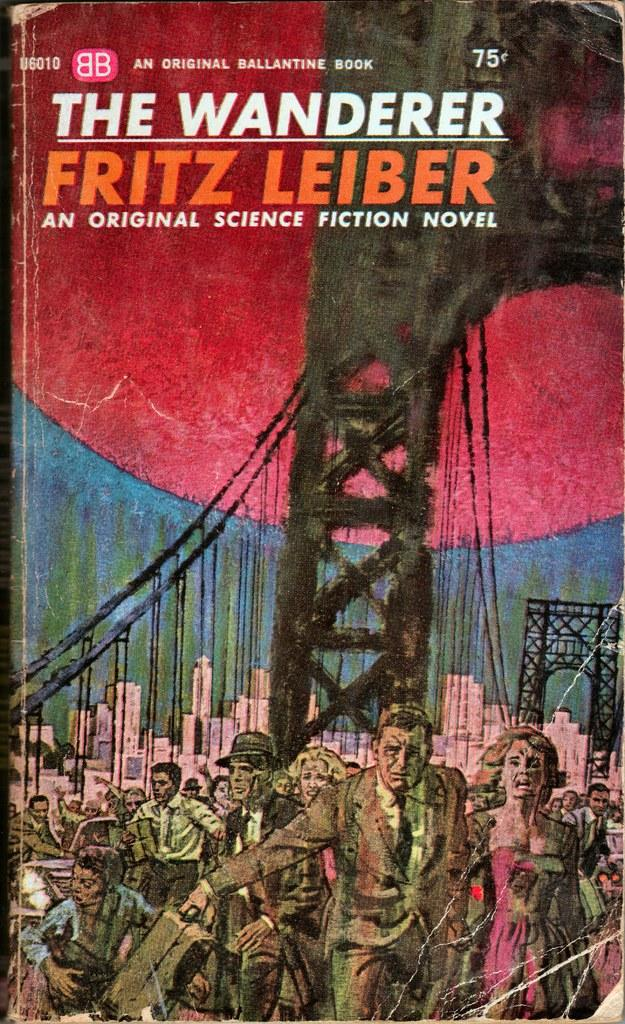<image>
Share a concise interpretation of the image provided. Book cover that says "The Wanderer" on the cover. 